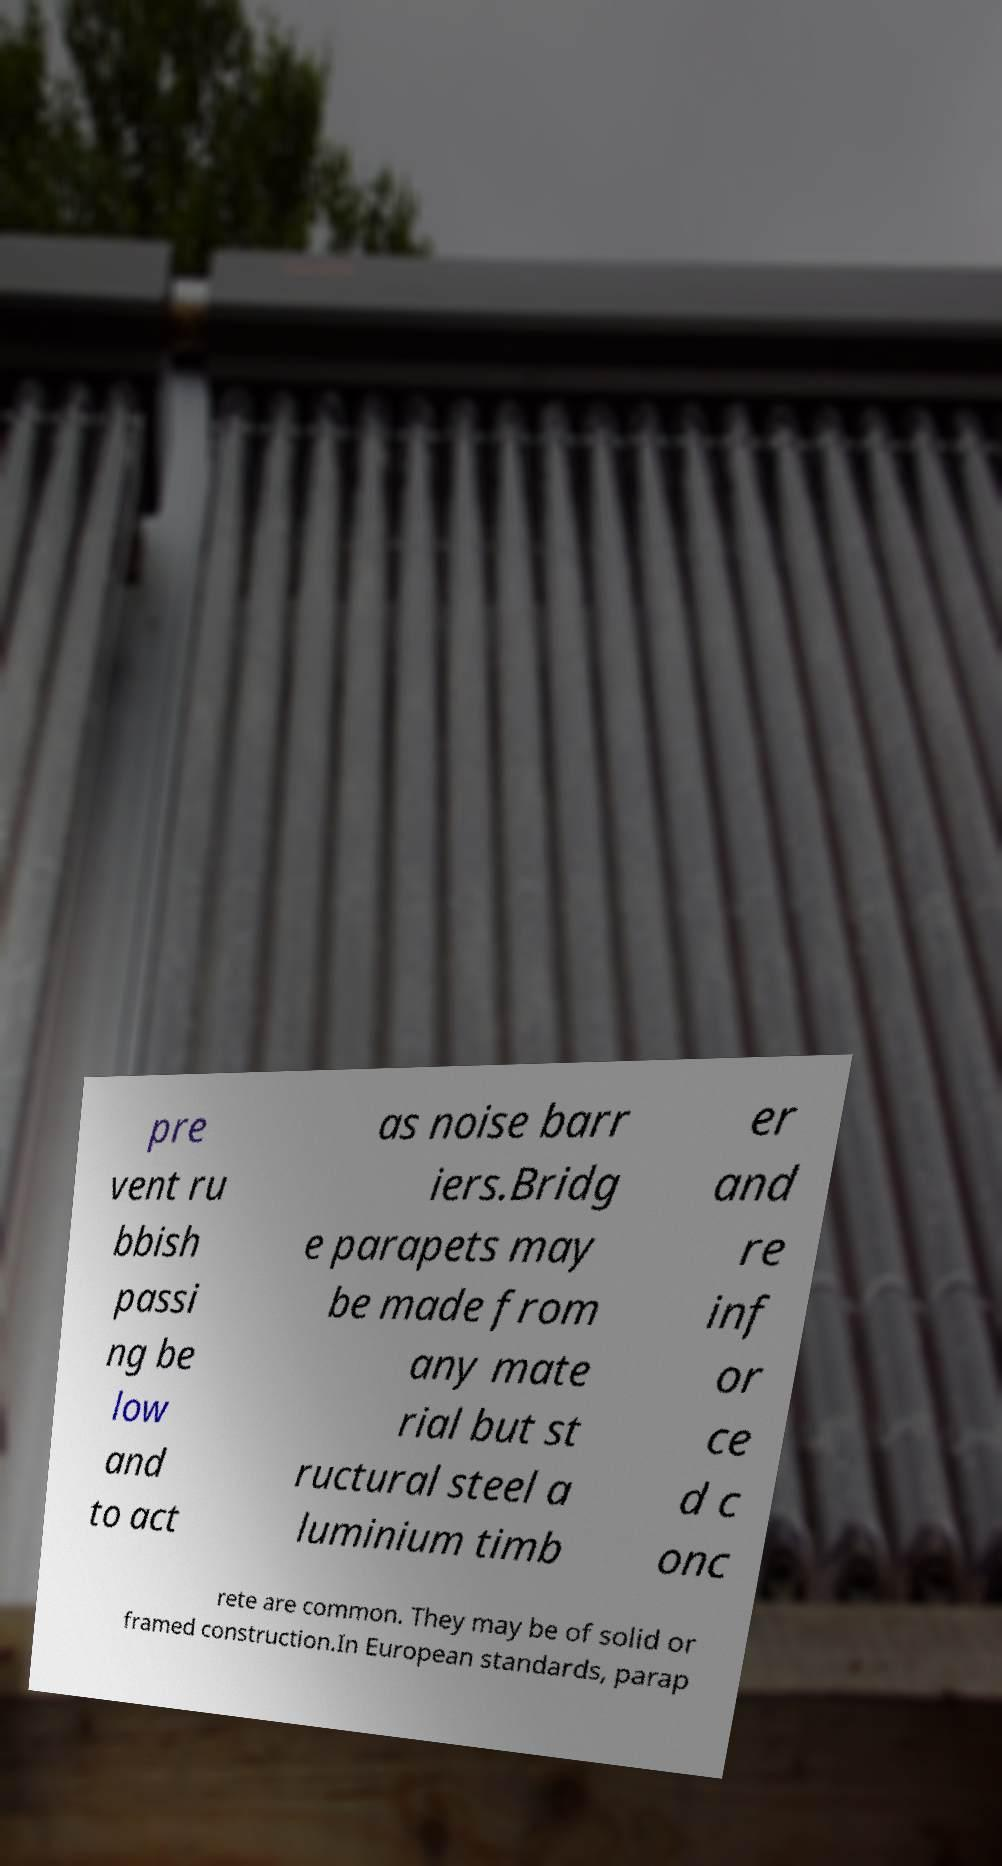Please identify and transcribe the text found in this image. pre vent ru bbish passi ng be low and to act as noise barr iers.Bridg e parapets may be made from any mate rial but st ructural steel a luminium timb er and re inf or ce d c onc rete are common. They may be of solid or framed construction.In European standards, parap 